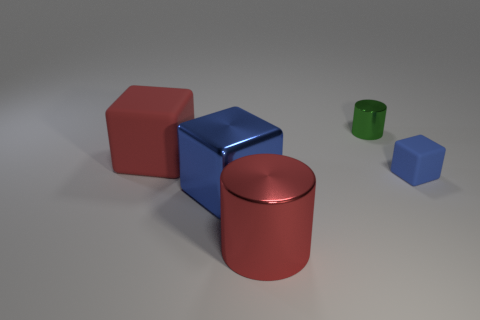What is the size of the metallic cube that is the same color as the tiny rubber object?
Offer a very short reply. Large. There is a large object that is behind the blue rubber object; is its color the same as the large cylinder?
Ensure brevity in your answer.  Yes. The red matte thing is what size?
Keep it short and to the point. Large. How many big objects are the same color as the small rubber cube?
Your answer should be compact. 1. Is the size of the cylinder that is in front of the small green shiny object the same as the green cylinder that is right of the red shiny object?
Your answer should be compact. No. What number of objects are blocks right of the small green cylinder or big red cylinders?
Provide a succinct answer. 2. What is the material of the tiny green cylinder?
Your answer should be compact. Metal. Do the red block and the green cylinder have the same size?
Give a very brief answer. No. What number of blocks are blue things or large blue metal objects?
Give a very brief answer. 2. There is a large cube in front of the rubber thing behind the tiny block; what color is it?
Offer a very short reply. Blue. 